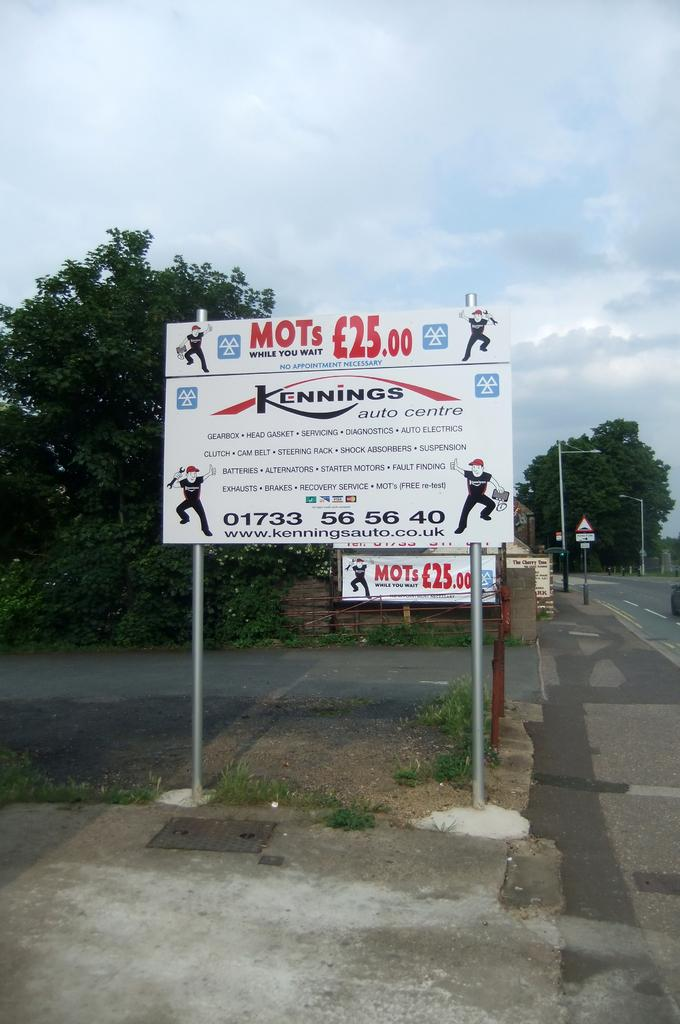<image>
Offer a succinct explanation of the picture presented. a road sign for Kennings Auto Centro along the side of a road 